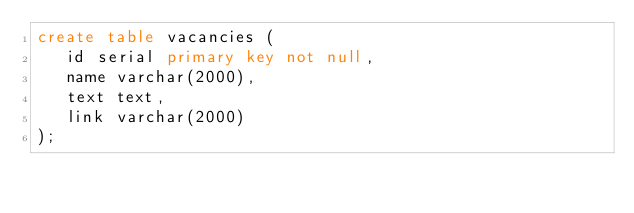Convert code to text. <code><loc_0><loc_0><loc_500><loc_500><_SQL_>create table vacancies (
   id serial primary key not null,
   name varchar(2000),
   text text,
   link varchar(2000)
);
</code> 